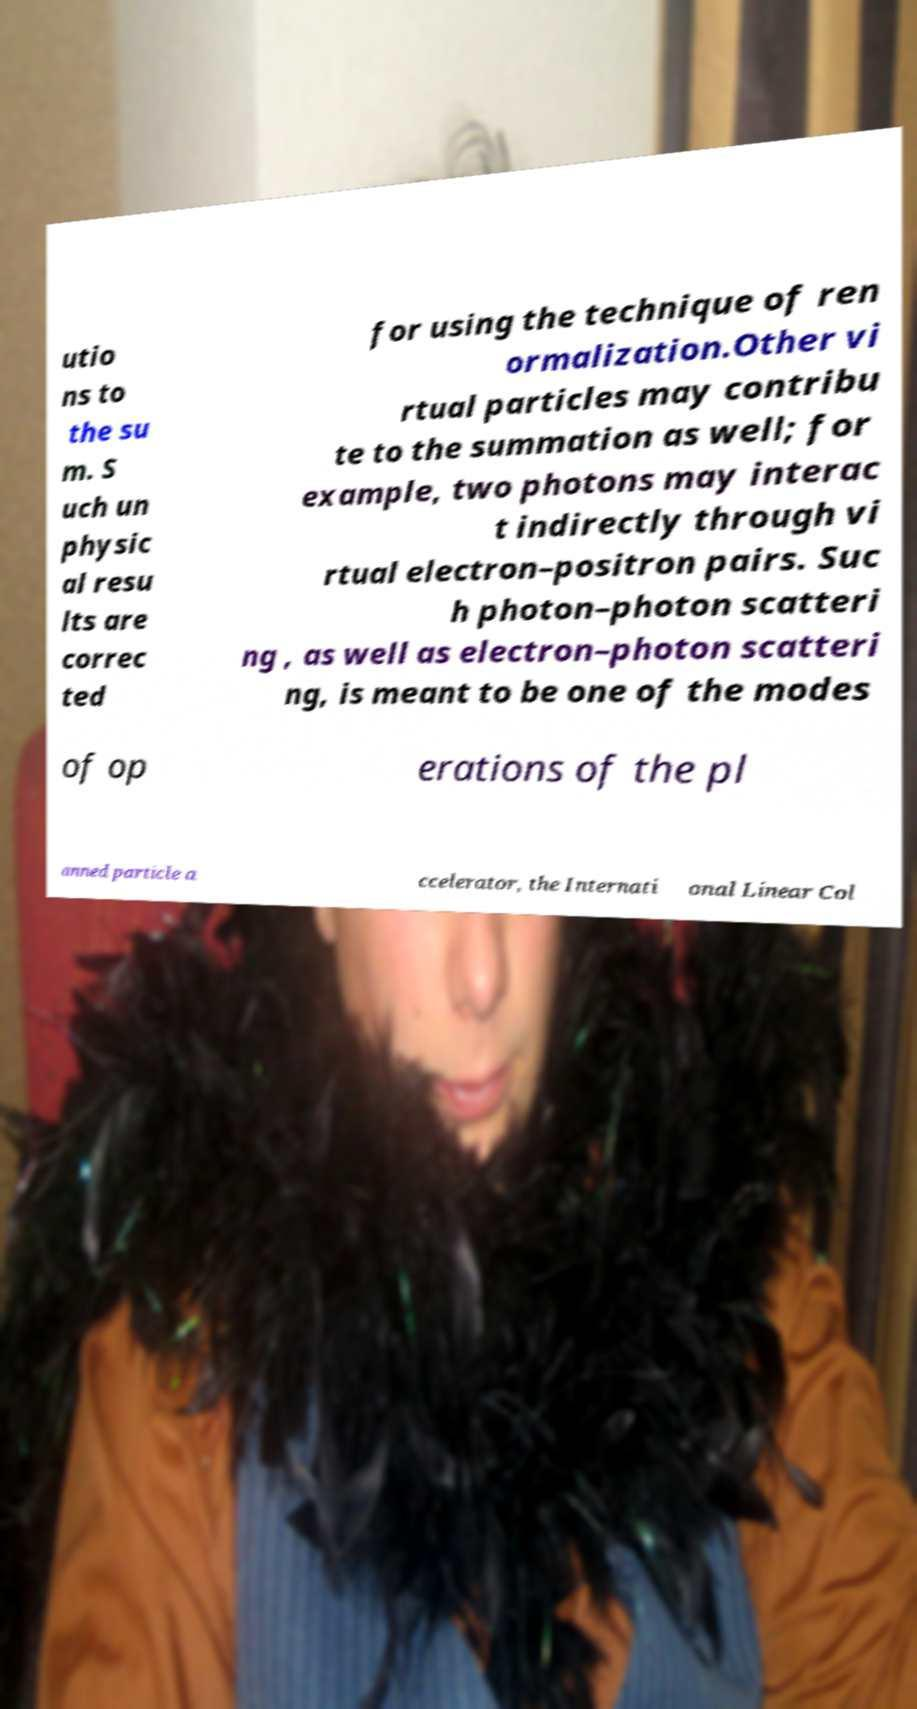Please identify and transcribe the text found in this image. utio ns to the su m. S uch un physic al resu lts are correc ted for using the technique of ren ormalization.Other vi rtual particles may contribu te to the summation as well; for example, two photons may interac t indirectly through vi rtual electron–positron pairs. Suc h photon–photon scatteri ng , as well as electron–photon scatteri ng, is meant to be one of the modes of op erations of the pl anned particle a ccelerator, the Internati onal Linear Col 